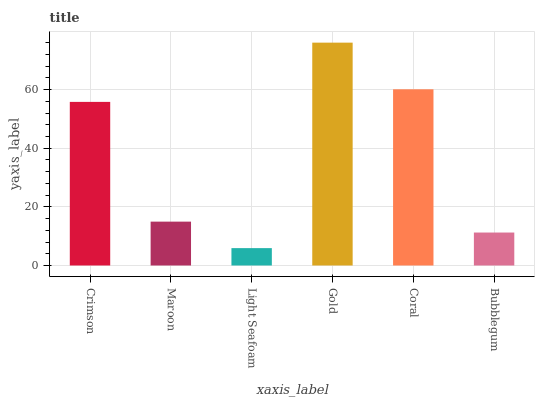Is Light Seafoam the minimum?
Answer yes or no. Yes. Is Gold the maximum?
Answer yes or no. Yes. Is Maroon the minimum?
Answer yes or no. No. Is Maroon the maximum?
Answer yes or no. No. Is Crimson greater than Maroon?
Answer yes or no. Yes. Is Maroon less than Crimson?
Answer yes or no. Yes. Is Maroon greater than Crimson?
Answer yes or no. No. Is Crimson less than Maroon?
Answer yes or no. No. Is Crimson the high median?
Answer yes or no. Yes. Is Maroon the low median?
Answer yes or no. Yes. Is Light Seafoam the high median?
Answer yes or no. No. Is Crimson the low median?
Answer yes or no. No. 